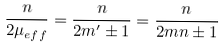<formula> <loc_0><loc_0><loc_500><loc_500>\frac { n } { 2 \mu _ { e f f } } = \frac { n } { 2 m ^ { \prime } \pm 1 } = \frac { n } { 2 m n \pm 1 }</formula> 